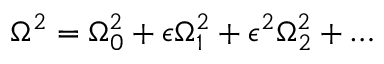<formula> <loc_0><loc_0><loc_500><loc_500>\Omega ^ { 2 } = \Omega _ { 0 } ^ { 2 } + \epsilon \Omega _ { 1 } ^ { 2 } + \epsilon ^ { 2 } \Omega _ { 2 } ^ { 2 } + \dots</formula> 